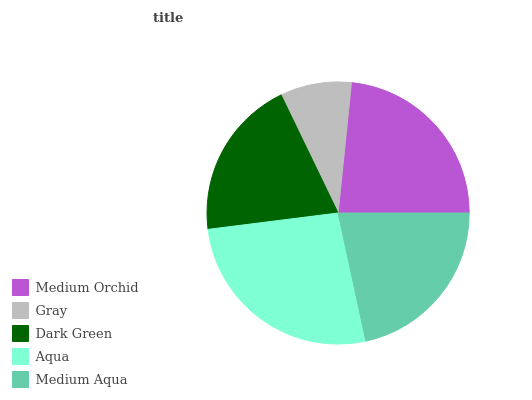Is Gray the minimum?
Answer yes or no. Yes. Is Aqua the maximum?
Answer yes or no. Yes. Is Dark Green the minimum?
Answer yes or no. No. Is Dark Green the maximum?
Answer yes or no. No. Is Dark Green greater than Gray?
Answer yes or no. Yes. Is Gray less than Dark Green?
Answer yes or no. Yes. Is Gray greater than Dark Green?
Answer yes or no. No. Is Dark Green less than Gray?
Answer yes or no. No. Is Medium Aqua the high median?
Answer yes or no. Yes. Is Medium Aqua the low median?
Answer yes or no. Yes. Is Gray the high median?
Answer yes or no. No. Is Aqua the low median?
Answer yes or no. No. 